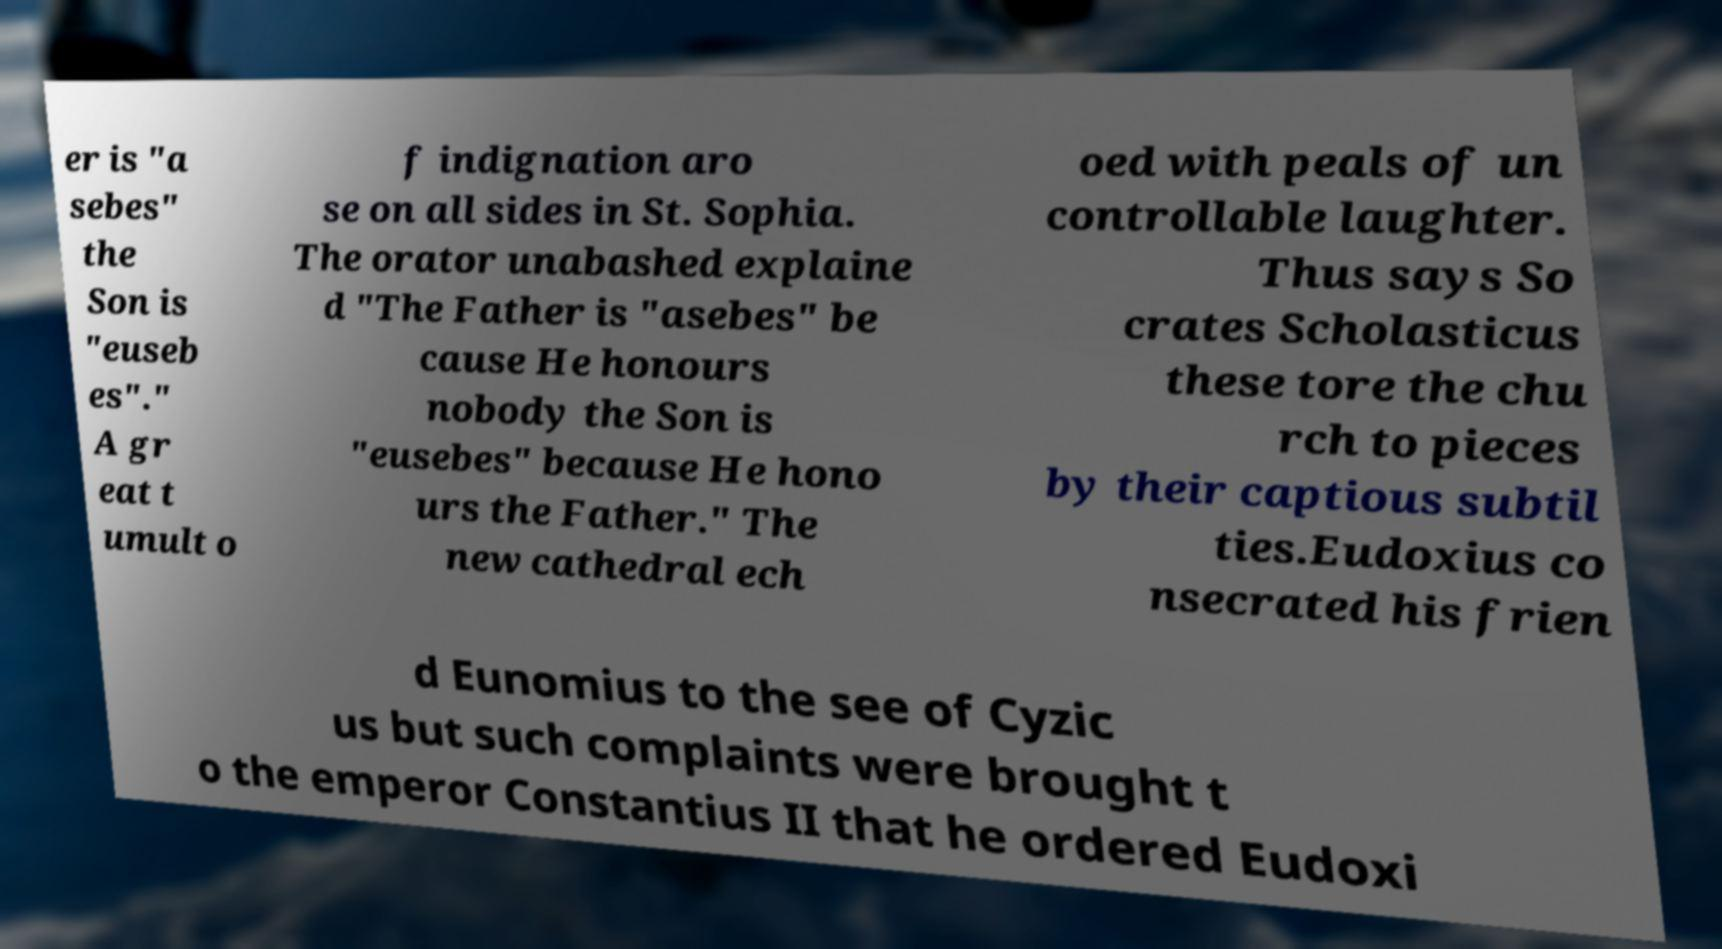For documentation purposes, I need the text within this image transcribed. Could you provide that? er is "a sebes" the Son is "euseb es"." A gr eat t umult o f indignation aro se on all sides in St. Sophia. The orator unabashed explaine d "The Father is "asebes" be cause He honours nobody the Son is "eusebes" because He hono urs the Father." The new cathedral ech oed with peals of un controllable laughter. Thus says So crates Scholasticus these tore the chu rch to pieces by their captious subtil ties.Eudoxius co nsecrated his frien d Eunomius to the see of Cyzic us but such complaints were brought t o the emperor Constantius II that he ordered Eudoxi 